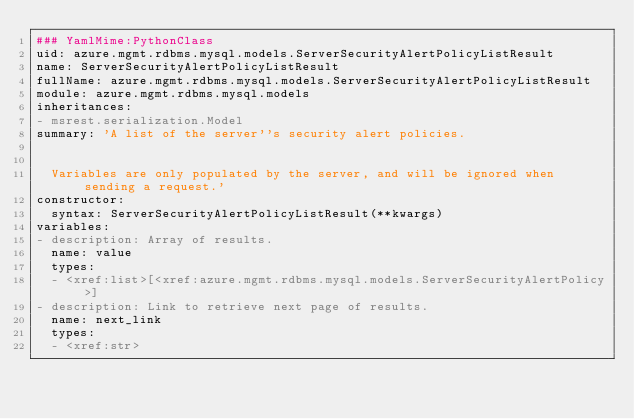Convert code to text. <code><loc_0><loc_0><loc_500><loc_500><_YAML_>### YamlMime:PythonClass
uid: azure.mgmt.rdbms.mysql.models.ServerSecurityAlertPolicyListResult
name: ServerSecurityAlertPolicyListResult
fullName: azure.mgmt.rdbms.mysql.models.ServerSecurityAlertPolicyListResult
module: azure.mgmt.rdbms.mysql.models
inheritances:
- msrest.serialization.Model
summary: 'A list of the server''s security alert policies.


  Variables are only populated by the server, and will be ignored when sending a request.'
constructor:
  syntax: ServerSecurityAlertPolicyListResult(**kwargs)
variables:
- description: Array of results.
  name: value
  types:
  - <xref:list>[<xref:azure.mgmt.rdbms.mysql.models.ServerSecurityAlertPolicy>]
- description: Link to retrieve next page of results.
  name: next_link
  types:
  - <xref:str>
</code> 